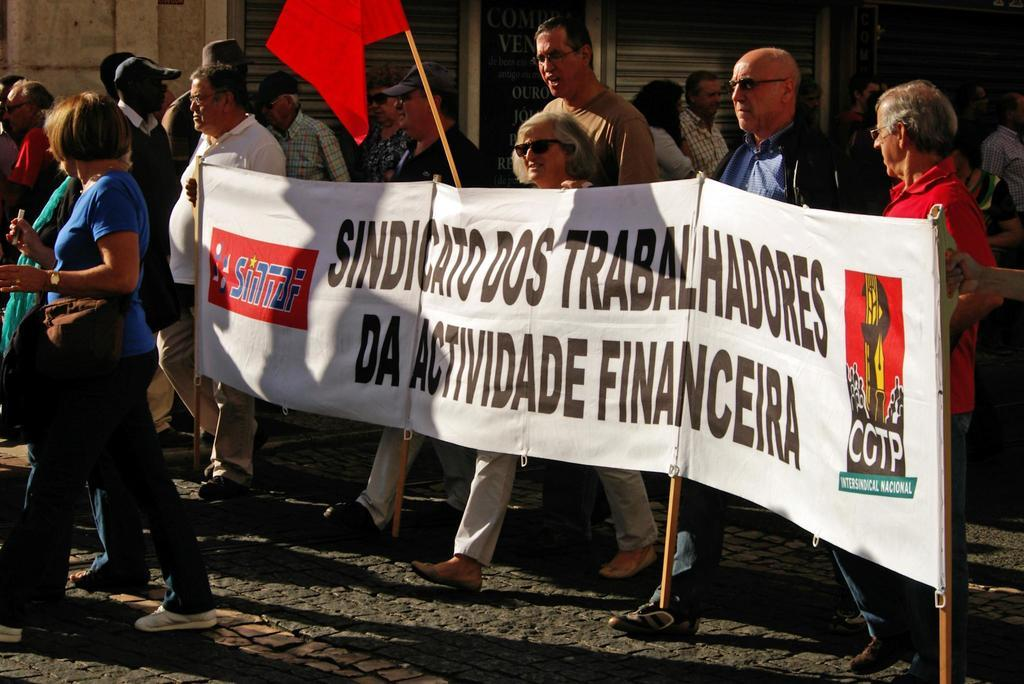Who or what is present in the image? There are people in the image. What are the people doing in the image? The people are walking. What are the people holding in the image? The people are holding a white color poster. What other object can be seen in the image? There is a red color flag in the image. How many eggs are visible on the red color flag in the image? There are no eggs visible on the red color flag in the image. What type of growth can be seen on the people in the image? There is no growth visible on the people in the image. 